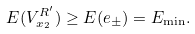<formula> <loc_0><loc_0><loc_500><loc_500>E ( V ^ { R ^ { \prime } } _ { x _ { 2 } } ) \geq E ( e _ { \pm } ) = E _ { \min } .</formula> 